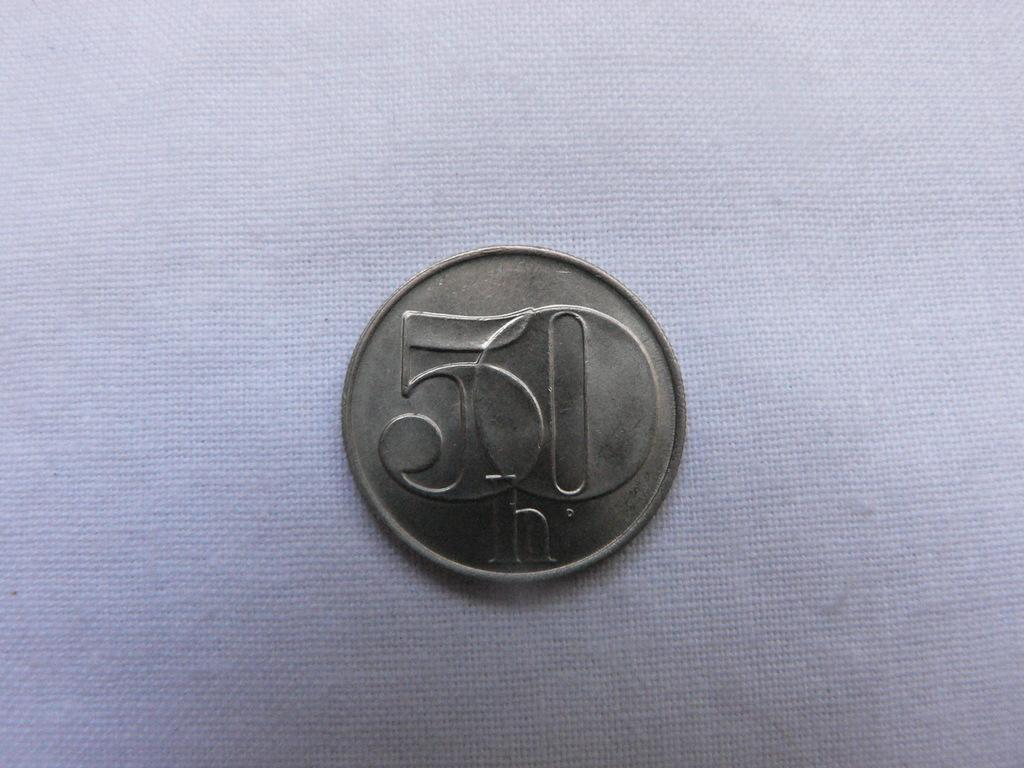Provide a one-sentence caption for the provided image. A coin on a table with 50 written on it. 